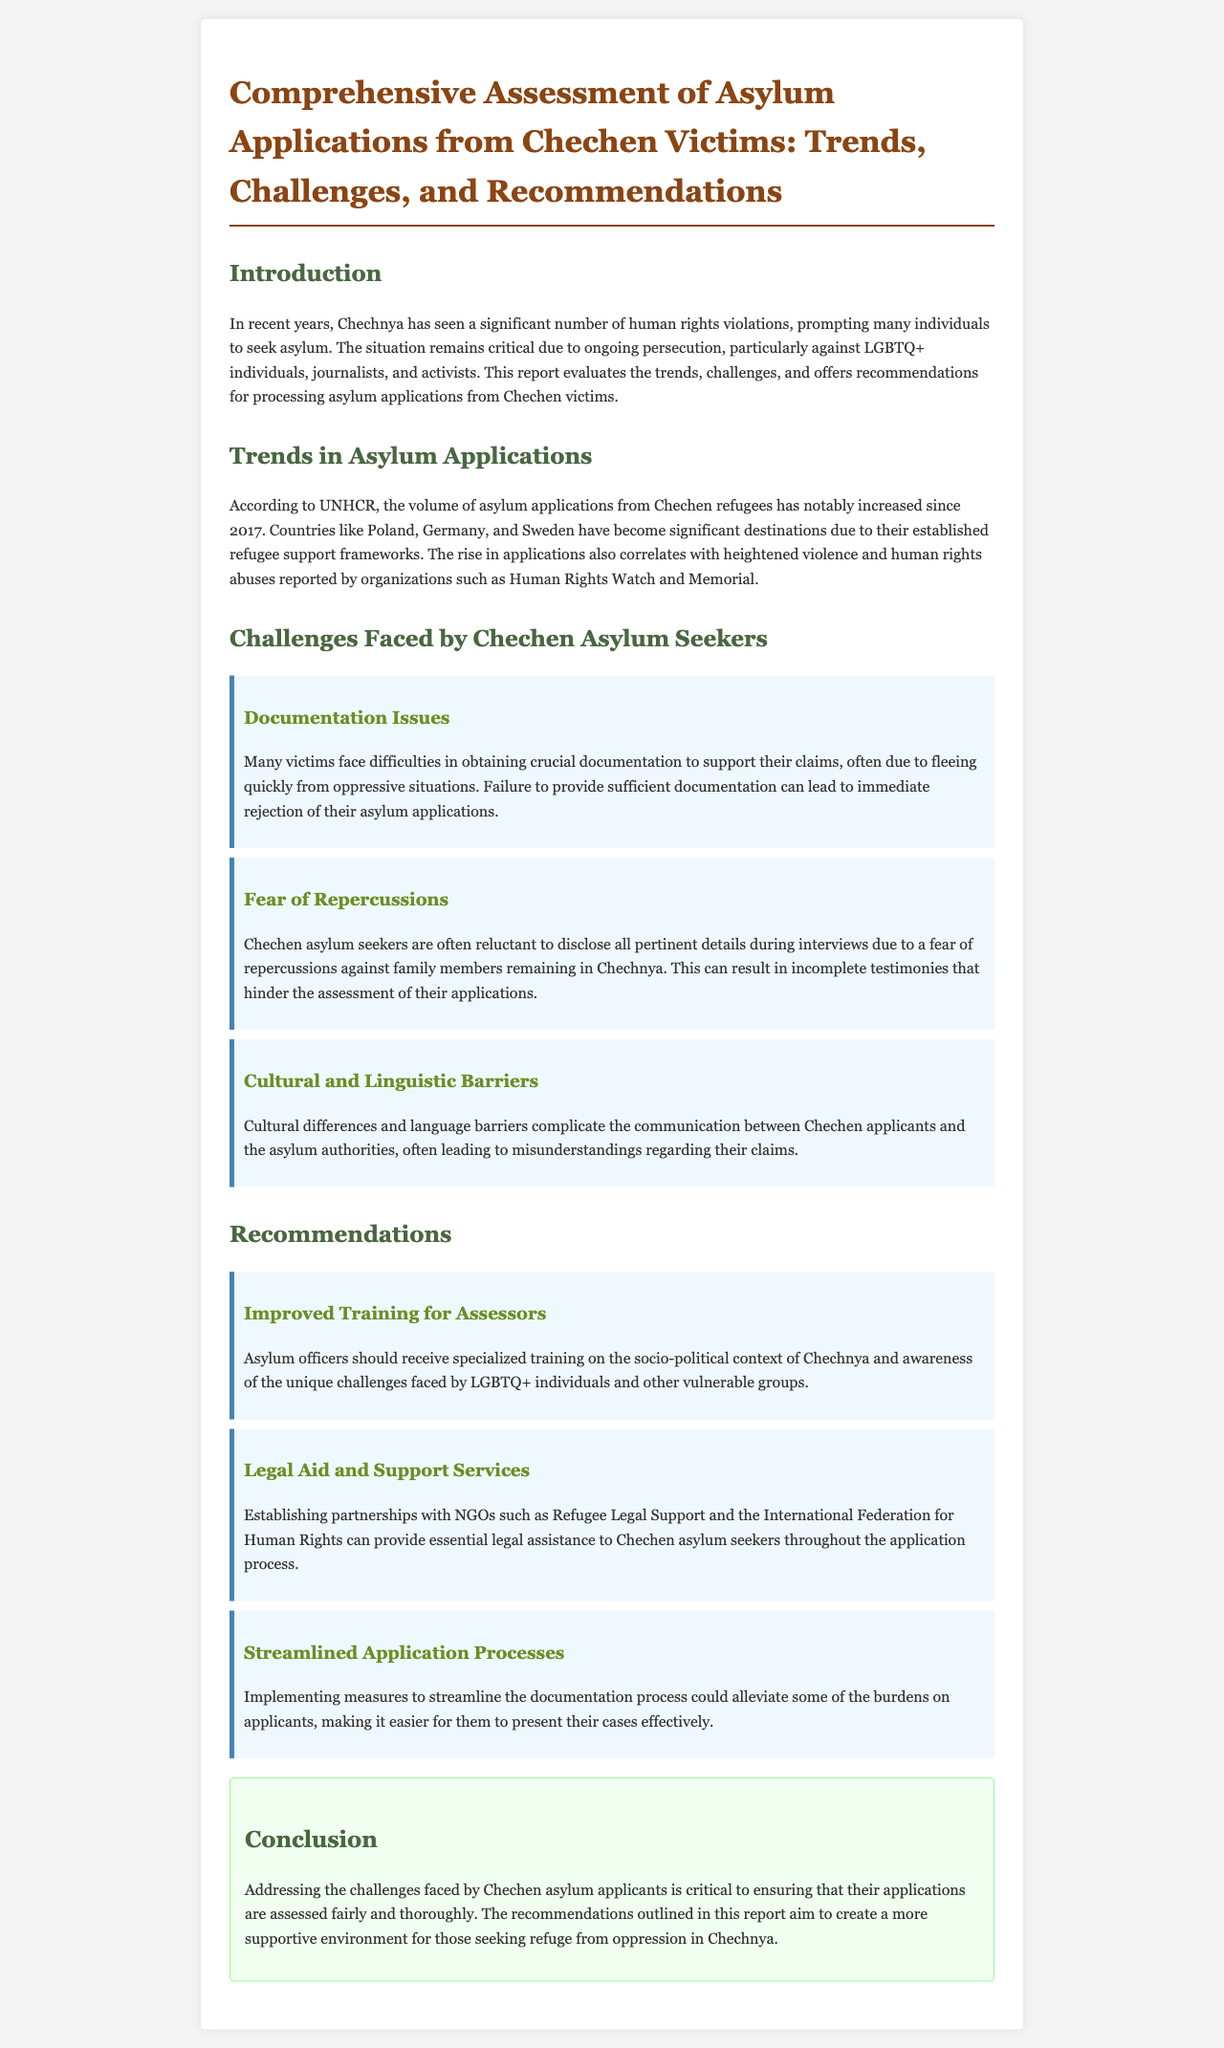what is the title of the report? The title of the report is found at the beginning and summarizes the subject matter it covers.
Answer: Comprehensive Assessment of Asylum Applications from Chechen Victims: Trends, Challenges, and Recommendations which countries are significant destinations for Chechen asylum seekers? The report lists specific countries known for receiving asylum applications from Chechen refugees based on their support frameworks.
Answer: Poland, Germany, and Sweden what year did the increase in asylum applications from Chechnya begin? The document indicates a specific year when the volume of applications notably increased.
Answer: 2017 what is one of the main challenges faced by Chechen asylum seekers regarding documentation? The report discusses specific documentation issues that influence the processing of applications.
Answer: Difficulties in obtaining crucial documentation which organization provides legal assistance that can be partnered with for Chechen asylum seekers? The report mentions specific NGOs that could provide support services for asylum seekers' legal needs.
Answer: Refugee Legal Support what type of training should asylum officers receive according to the report? The report suggests a specialized type of training for those assessing asylum applications to improve understanding of unique cases.
Answer: Specialized training on the socio-political context of Chechnya how does fear affect asylum seekers during the application process? The report describes a specific fear related to family safety impacting the disclosure of information.
Answer: Fear of repercussions against family members what is a recommended action to streamline the asylum application process? The document lists methods aimed at easing the burden of the application process on asylum seekers.
Answer: Streamlined documentation process what is the main goal of the recommendations in the report? The report outlines the primary objective of the suggested actions in relation to asylum applications.
Answer: Create a more supportive environment for seekers 